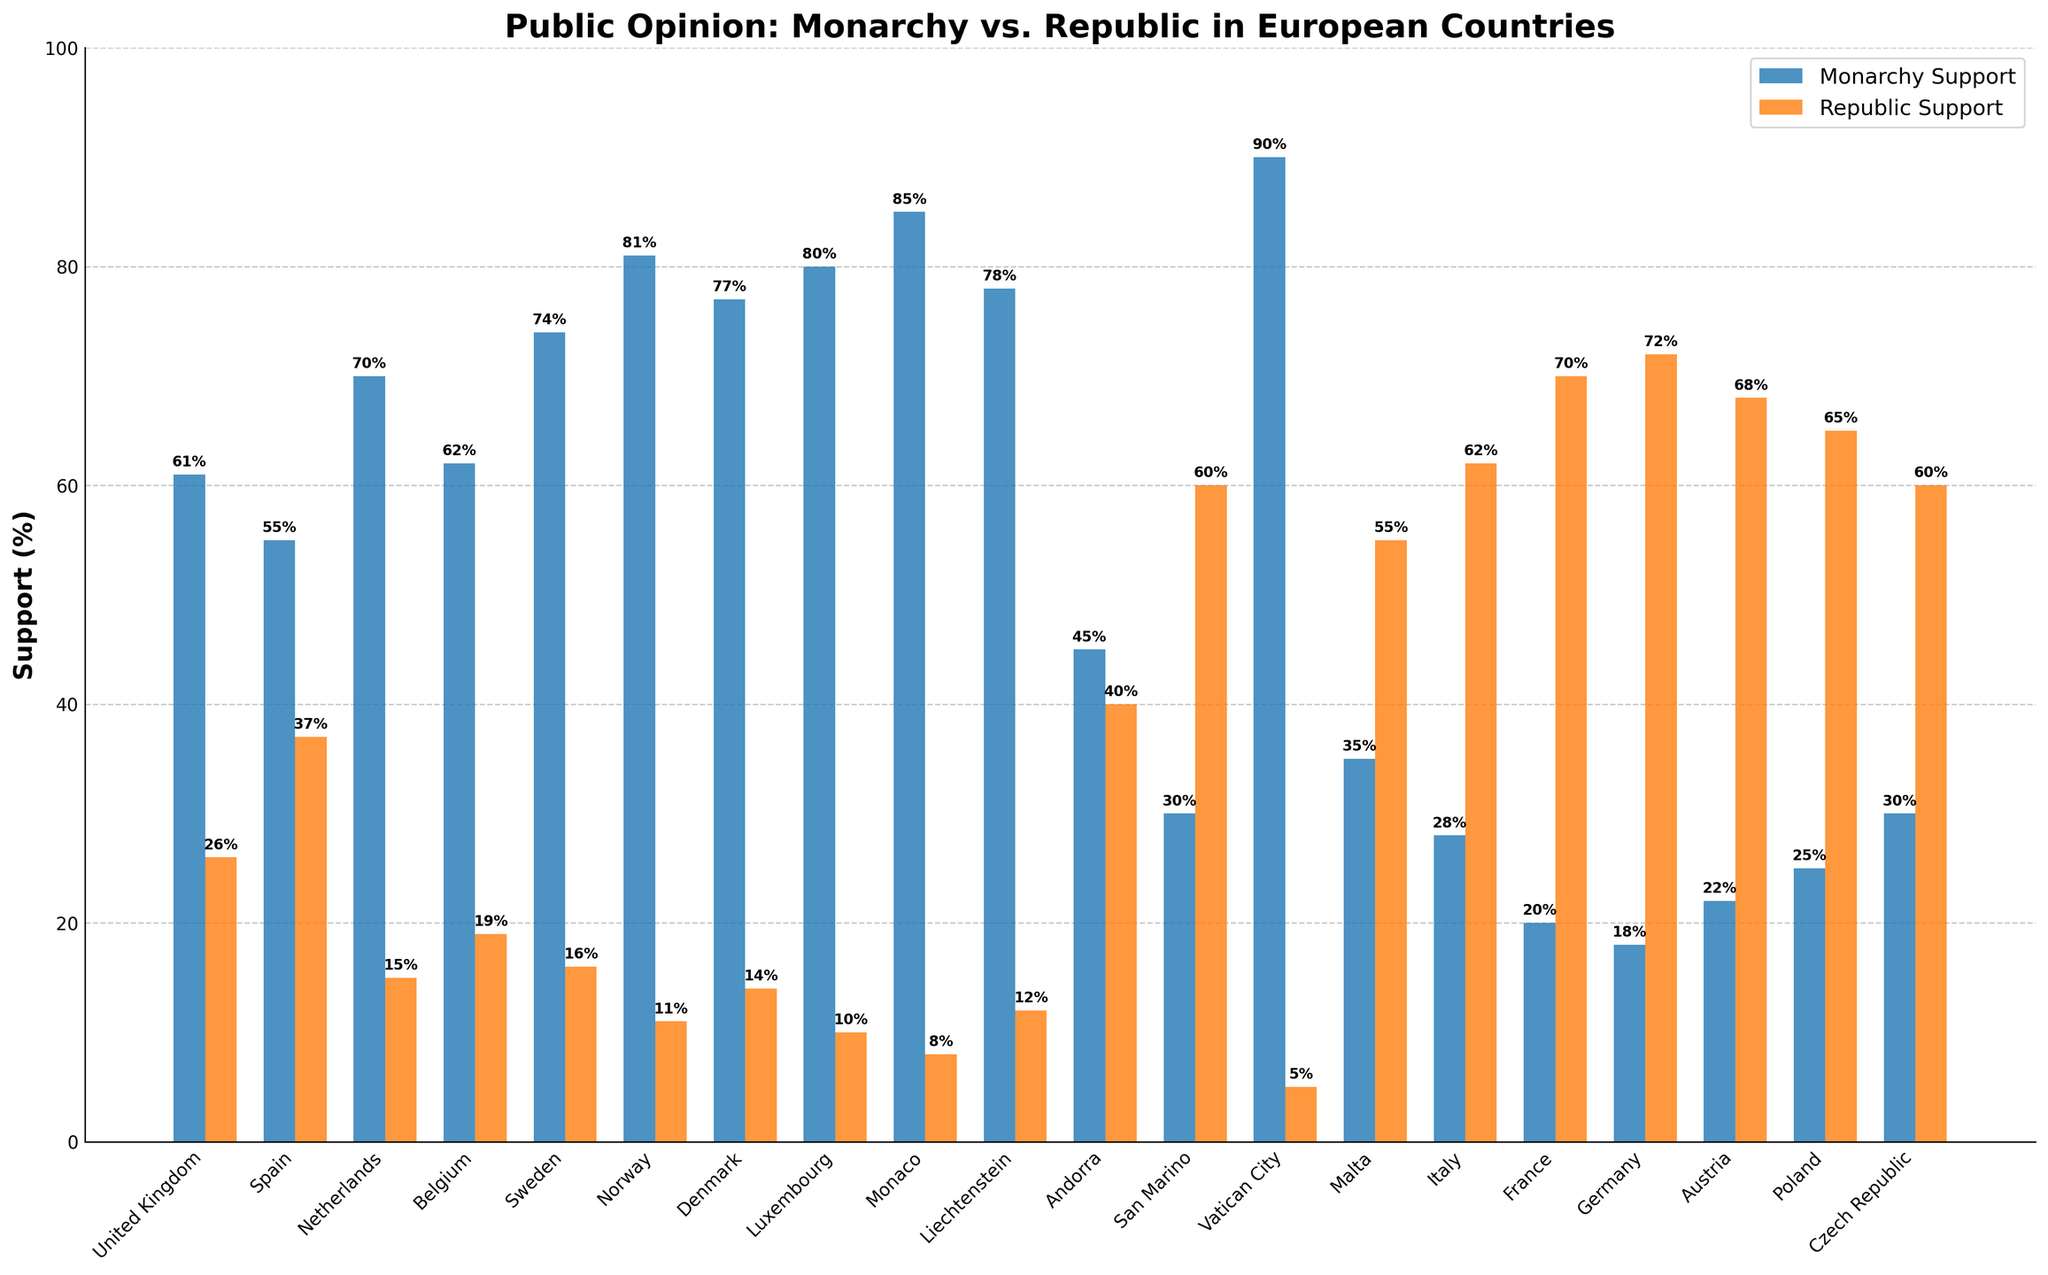What percentage of people support a monarchy in Norway? Look for the bar representing Norway in the chart, and identify the height of the bar for Monarchy Support. It shows 81%.
Answer: 81% Which country has the highest support for a republic? Identify the tallest bar for Republic Support. France shows 70%, which is the highest among all countries.
Answer: France How much greater is the monarchy support in Denmark compared to the Netherlands? Locate the heights of the Monarchy Support bars for Denmark (77%) and the Netherlands (70%), then calculate the difference: 77% - 70% = 7%.
Answer: 7% What is the average monarchy support across Luxembourg, Monaco, and Vatican City? Identify the values for these three countries: Luxembourg (80%), Monaco (85%), and Vatican City (90%). Calculate the average: (80% + 85% + 90%) / 3 = 85%.
Answer: 85% Which countries have a republic support greater than 60%? Identify the bars where Republic Support is greater than 60%. These countries are Italy (62%), France (70%), Germany (72%), and Austria (68%).
Answer: Italy, France, Germany, Austria How much more is the republic support in Germany compared to the United Kingdom? Identify the republic support values for Germany (72%) and the United Kingdom (26%), then calculate the difference: 72% - 26% = 46%.
Answer: 46% Which country has the largest difference between monarchy support and republic support? Calculate the difference for each country and identify the largest one. Vatican City has the largest difference: 90% (Monarchy) - 5% (Republic) = 85%.
Answer: Vatican City What is the total support for monarchy in Andorra, San Marino, and Malta combined? Identify the values for monarchy support: Andorra (45%), San Marino (30%), and Malta (35%). Sum them up: 45% + 30% + 35% = 110%.
Answer: 110% Which country has a visually noticeable difference in support for monarchy vs. republic with monarchy being more favored? Look for countries where the Monarchy Support bar is significantly higher than Republic Support. Norway (81% vs. 11%) is a clear example.
Answer: Norway How does the support for a republic in Poland compare to that in Malta? Identify the republic support values: Poland (65%) and Malta (55%). Poland has a higher republic support by 10 percentage points.
Answer: Poland 